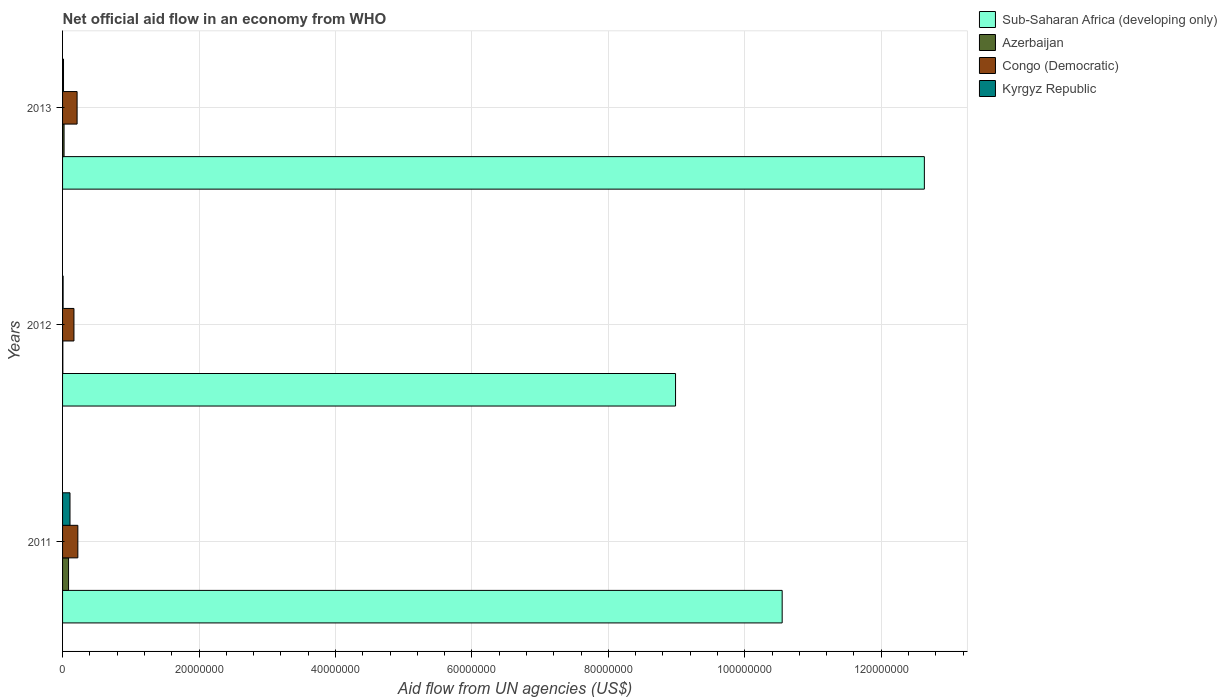How many bars are there on the 2nd tick from the top?
Offer a very short reply. 4. How many bars are there on the 3rd tick from the bottom?
Provide a succinct answer. 4. What is the label of the 1st group of bars from the top?
Provide a short and direct response. 2013. What is the net official aid flow in Kyrgyz Republic in 2011?
Your response must be concise. 1.09e+06. Across all years, what is the maximum net official aid flow in Congo (Democratic)?
Provide a short and direct response. 2.24e+06. In which year was the net official aid flow in Congo (Democratic) maximum?
Offer a very short reply. 2011. In which year was the net official aid flow in Kyrgyz Republic minimum?
Ensure brevity in your answer.  2012. What is the total net official aid flow in Congo (Democratic) in the graph?
Your answer should be very brief. 6.04e+06. What is the difference between the net official aid flow in Sub-Saharan Africa (developing only) in 2011 and the net official aid flow in Kyrgyz Republic in 2012?
Give a very brief answer. 1.05e+08. What is the average net official aid flow in Kyrgyz Republic per year?
Make the answer very short. 4.37e+05. In the year 2012, what is the difference between the net official aid flow in Congo (Democratic) and net official aid flow in Azerbaijan?
Provide a succinct answer. 1.63e+06. In how many years, is the net official aid flow in Kyrgyz Republic greater than 112000000 US$?
Offer a very short reply. 0. What is the ratio of the net official aid flow in Congo (Democratic) in 2012 to that in 2013?
Offer a very short reply. 0.78. Is the difference between the net official aid flow in Congo (Democratic) in 2012 and 2013 greater than the difference between the net official aid flow in Azerbaijan in 2012 and 2013?
Keep it short and to the point. No. What is the difference between the highest and the second highest net official aid flow in Sub-Saharan Africa (developing only)?
Your answer should be very brief. 2.08e+07. What is the difference between the highest and the lowest net official aid flow in Kyrgyz Republic?
Keep it short and to the point. 1.01e+06. What does the 3rd bar from the top in 2013 represents?
Your answer should be very brief. Azerbaijan. What does the 3rd bar from the bottom in 2012 represents?
Your answer should be compact. Congo (Democratic). How many years are there in the graph?
Offer a very short reply. 3. What is the difference between two consecutive major ticks on the X-axis?
Offer a very short reply. 2.00e+07. Are the values on the major ticks of X-axis written in scientific E-notation?
Make the answer very short. No. Does the graph contain any zero values?
Ensure brevity in your answer.  No. Where does the legend appear in the graph?
Offer a very short reply. Top right. How many legend labels are there?
Offer a terse response. 4. How are the legend labels stacked?
Provide a short and direct response. Vertical. What is the title of the graph?
Ensure brevity in your answer.  Net official aid flow in an economy from WHO. What is the label or title of the X-axis?
Offer a very short reply. Aid flow from UN agencies (US$). What is the Aid flow from UN agencies (US$) of Sub-Saharan Africa (developing only) in 2011?
Your answer should be very brief. 1.05e+08. What is the Aid flow from UN agencies (US$) of Azerbaijan in 2011?
Make the answer very short. 8.80e+05. What is the Aid flow from UN agencies (US$) of Congo (Democratic) in 2011?
Keep it short and to the point. 2.24e+06. What is the Aid flow from UN agencies (US$) in Kyrgyz Republic in 2011?
Ensure brevity in your answer.  1.09e+06. What is the Aid flow from UN agencies (US$) of Sub-Saharan Africa (developing only) in 2012?
Provide a succinct answer. 8.98e+07. What is the Aid flow from UN agencies (US$) in Congo (Democratic) in 2012?
Your response must be concise. 1.67e+06. What is the Aid flow from UN agencies (US$) of Sub-Saharan Africa (developing only) in 2013?
Provide a short and direct response. 1.26e+08. What is the Aid flow from UN agencies (US$) in Congo (Democratic) in 2013?
Provide a succinct answer. 2.13e+06. Across all years, what is the maximum Aid flow from UN agencies (US$) in Sub-Saharan Africa (developing only)?
Ensure brevity in your answer.  1.26e+08. Across all years, what is the maximum Aid flow from UN agencies (US$) of Azerbaijan?
Your answer should be very brief. 8.80e+05. Across all years, what is the maximum Aid flow from UN agencies (US$) of Congo (Democratic)?
Offer a terse response. 2.24e+06. Across all years, what is the maximum Aid flow from UN agencies (US$) of Kyrgyz Republic?
Offer a terse response. 1.09e+06. Across all years, what is the minimum Aid flow from UN agencies (US$) of Sub-Saharan Africa (developing only)?
Keep it short and to the point. 8.98e+07. Across all years, what is the minimum Aid flow from UN agencies (US$) of Azerbaijan?
Offer a very short reply. 4.00e+04. Across all years, what is the minimum Aid flow from UN agencies (US$) of Congo (Democratic)?
Offer a very short reply. 1.67e+06. Across all years, what is the minimum Aid flow from UN agencies (US$) of Kyrgyz Republic?
Offer a terse response. 8.00e+04. What is the total Aid flow from UN agencies (US$) in Sub-Saharan Africa (developing only) in the graph?
Keep it short and to the point. 3.22e+08. What is the total Aid flow from UN agencies (US$) in Azerbaijan in the graph?
Keep it short and to the point. 1.14e+06. What is the total Aid flow from UN agencies (US$) of Congo (Democratic) in the graph?
Offer a terse response. 6.04e+06. What is the total Aid flow from UN agencies (US$) of Kyrgyz Republic in the graph?
Keep it short and to the point. 1.31e+06. What is the difference between the Aid flow from UN agencies (US$) of Sub-Saharan Africa (developing only) in 2011 and that in 2012?
Keep it short and to the point. 1.56e+07. What is the difference between the Aid flow from UN agencies (US$) in Azerbaijan in 2011 and that in 2012?
Provide a short and direct response. 8.40e+05. What is the difference between the Aid flow from UN agencies (US$) of Congo (Democratic) in 2011 and that in 2012?
Provide a succinct answer. 5.70e+05. What is the difference between the Aid flow from UN agencies (US$) in Kyrgyz Republic in 2011 and that in 2012?
Your response must be concise. 1.01e+06. What is the difference between the Aid flow from UN agencies (US$) in Sub-Saharan Africa (developing only) in 2011 and that in 2013?
Provide a short and direct response. -2.08e+07. What is the difference between the Aid flow from UN agencies (US$) of Congo (Democratic) in 2011 and that in 2013?
Provide a succinct answer. 1.10e+05. What is the difference between the Aid flow from UN agencies (US$) of Kyrgyz Republic in 2011 and that in 2013?
Give a very brief answer. 9.50e+05. What is the difference between the Aid flow from UN agencies (US$) in Sub-Saharan Africa (developing only) in 2012 and that in 2013?
Offer a very short reply. -3.65e+07. What is the difference between the Aid flow from UN agencies (US$) of Azerbaijan in 2012 and that in 2013?
Ensure brevity in your answer.  -1.80e+05. What is the difference between the Aid flow from UN agencies (US$) of Congo (Democratic) in 2012 and that in 2013?
Offer a terse response. -4.60e+05. What is the difference between the Aid flow from UN agencies (US$) of Kyrgyz Republic in 2012 and that in 2013?
Keep it short and to the point. -6.00e+04. What is the difference between the Aid flow from UN agencies (US$) of Sub-Saharan Africa (developing only) in 2011 and the Aid flow from UN agencies (US$) of Azerbaijan in 2012?
Ensure brevity in your answer.  1.05e+08. What is the difference between the Aid flow from UN agencies (US$) of Sub-Saharan Africa (developing only) in 2011 and the Aid flow from UN agencies (US$) of Congo (Democratic) in 2012?
Offer a very short reply. 1.04e+08. What is the difference between the Aid flow from UN agencies (US$) in Sub-Saharan Africa (developing only) in 2011 and the Aid flow from UN agencies (US$) in Kyrgyz Republic in 2012?
Make the answer very short. 1.05e+08. What is the difference between the Aid flow from UN agencies (US$) in Azerbaijan in 2011 and the Aid flow from UN agencies (US$) in Congo (Democratic) in 2012?
Your response must be concise. -7.90e+05. What is the difference between the Aid flow from UN agencies (US$) of Congo (Democratic) in 2011 and the Aid flow from UN agencies (US$) of Kyrgyz Republic in 2012?
Provide a succinct answer. 2.16e+06. What is the difference between the Aid flow from UN agencies (US$) in Sub-Saharan Africa (developing only) in 2011 and the Aid flow from UN agencies (US$) in Azerbaijan in 2013?
Give a very brief answer. 1.05e+08. What is the difference between the Aid flow from UN agencies (US$) in Sub-Saharan Africa (developing only) in 2011 and the Aid flow from UN agencies (US$) in Congo (Democratic) in 2013?
Offer a very short reply. 1.03e+08. What is the difference between the Aid flow from UN agencies (US$) in Sub-Saharan Africa (developing only) in 2011 and the Aid flow from UN agencies (US$) in Kyrgyz Republic in 2013?
Make the answer very short. 1.05e+08. What is the difference between the Aid flow from UN agencies (US$) of Azerbaijan in 2011 and the Aid flow from UN agencies (US$) of Congo (Democratic) in 2013?
Give a very brief answer. -1.25e+06. What is the difference between the Aid flow from UN agencies (US$) in Azerbaijan in 2011 and the Aid flow from UN agencies (US$) in Kyrgyz Republic in 2013?
Offer a terse response. 7.40e+05. What is the difference between the Aid flow from UN agencies (US$) of Congo (Democratic) in 2011 and the Aid flow from UN agencies (US$) of Kyrgyz Republic in 2013?
Make the answer very short. 2.10e+06. What is the difference between the Aid flow from UN agencies (US$) in Sub-Saharan Africa (developing only) in 2012 and the Aid flow from UN agencies (US$) in Azerbaijan in 2013?
Keep it short and to the point. 8.96e+07. What is the difference between the Aid flow from UN agencies (US$) of Sub-Saharan Africa (developing only) in 2012 and the Aid flow from UN agencies (US$) of Congo (Democratic) in 2013?
Ensure brevity in your answer.  8.77e+07. What is the difference between the Aid flow from UN agencies (US$) in Sub-Saharan Africa (developing only) in 2012 and the Aid flow from UN agencies (US$) in Kyrgyz Republic in 2013?
Offer a terse response. 8.97e+07. What is the difference between the Aid flow from UN agencies (US$) in Azerbaijan in 2012 and the Aid flow from UN agencies (US$) in Congo (Democratic) in 2013?
Keep it short and to the point. -2.09e+06. What is the difference between the Aid flow from UN agencies (US$) in Azerbaijan in 2012 and the Aid flow from UN agencies (US$) in Kyrgyz Republic in 2013?
Make the answer very short. -1.00e+05. What is the difference between the Aid flow from UN agencies (US$) in Congo (Democratic) in 2012 and the Aid flow from UN agencies (US$) in Kyrgyz Republic in 2013?
Provide a short and direct response. 1.53e+06. What is the average Aid flow from UN agencies (US$) in Sub-Saharan Africa (developing only) per year?
Give a very brief answer. 1.07e+08. What is the average Aid flow from UN agencies (US$) in Azerbaijan per year?
Offer a terse response. 3.80e+05. What is the average Aid flow from UN agencies (US$) of Congo (Democratic) per year?
Provide a short and direct response. 2.01e+06. What is the average Aid flow from UN agencies (US$) of Kyrgyz Republic per year?
Ensure brevity in your answer.  4.37e+05. In the year 2011, what is the difference between the Aid flow from UN agencies (US$) of Sub-Saharan Africa (developing only) and Aid flow from UN agencies (US$) of Azerbaijan?
Provide a succinct answer. 1.05e+08. In the year 2011, what is the difference between the Aid flow from UN agencies (US$) in Sub-Saharan Africa (developing only) and Aid flow from UN agencies (US$) in Congo (Democratic)?
Your answer should be compact. 1.03e+08. In the year 2011, what is the difference between the Aid flow from UN agencies (US$) of Sub-Saharan Africa (developing only) and Aid flow from UN agencies (US$) of Kyrgyz Republic?
Keep it short and to the point. 1.04e+08. In the year 2011, what is the difference between the Aid flow from UN agencies (US$) of Azerbaijan and Aid flow from UN agencies (US$) of Congo (Democratic)?
Offer a very short reply. -1.36e+06. In the year 2011, what is the difference between the Aid flow from UN agencies (US$) in Congo (Democratic) and Aid flow from UN agencies (US$) in Kyrgyz Republic?
Give a very brief answer. 1.15e+06. In the year 2012, what is the difference between the Aid flow from UN agencies (US$) of Sub-Saharan Africa (developing only) and Aid flow from UN agencies (US$) of Azerbaijan?
Your answer should be very brief. 8.98e+07. In the year 2012, what is the difference between the Aid flow from UN agencies (US$) of Sub-Saharan Africa (developing only) and Aid flow from UN agencies (US$) of Congo (Democratic)?
Offer a very short reply. 8.82e+07. In the year 2012, what is the difference between the Aid flow from UN agencies (US$) of Sub-Saharan Africa (developing only) and Aid flow from UN agencies (US$) of Kyrgyz Republic?
Provide a short and direct response. 8.98e+07. In the year 2012, what is the difference between the Aid flow from UN agencies (US$) in Azerbaijan and Aid flow from UN agencies (US$) in Congo (Democratic)?
Provide a short and direct response. -1.63e+06. In the year 2012, what is the difference between the Aid flow from UN agencies (US$) of Congo (Democratic) and Aid flow from UN agencies (US$) of Kyrgyz Republic?
Offer a terse response. 1.59e+06. In the year 2013, what is the difference between the Aid flow from UN agencies (US$) in Sub-Saharan Africa (developing only) and Aid flow from UN agencies (US$) in Azerbaijan?
Your response must be concise. 1.26e+08. In the year 2013, what is the difference between the Aid flow from UN agencies (US$) in Sub-Saharan Africa (developing only) and Aid flow from UN agencies (US$) in Congo (Democratic)?
Give a very brief answer. 1.24e+08. In the year 2013, what is the difference between the Aid flow from UN agencies (US$) of Sub-Saharan Africa (developing only) and Aid flow from UN agencies (US$) of Kyrgyz Republic?
Make the answer very short. 1.26e+08. In the year 2013, what is the difference between the Aid flow from UN agencies (US$) of Azerbaijan and Aid flow from UN agencies (US$) of Congo (Democratic)?
Ensure brevity in your answer.  -1.91e+06. In the year 2013, what is the difference between the Aid flow from UN agencies (US$) of Azerbaijan and Aid flow from UN agencies (US$) of Kyrgyz Republic?
Make the answer very short. 8.00e+04. In the year 2013, what is the difference between the Aid flow from UN agencies (US$) of Congo (Democratic) and Aid flow from UN agencies (US$) of Kyrgyz Republic?
Keep it short and to the point. 1.99e+06. What is the ratio of the Aid flow from UN agencies (US$) in Sub-Saharan Africa (developing only) in 2011 to that in 2012?
Offer a very short reply. 1.17. What is the ratio of the Aid flow from UN agencies (US$) of Azerbaijan in 2011 to that in 2012?
Ensure brevity in your answer.  22. What is the ratio of the Aid flow from UN agencies (US$) of Congo (Democratic) in 2011 to that in 2012?
Provide a short and direct response. 1.34. What is the ratio of the Aid flow from UN agencies (US$) in Kyrgyz Republic in 2011 to that in 2012?
Offer a very short reply. 13.62. What is the ratio of the Aid flow from UN agencies (US$) in Sub-Saharan Africa (developing only) in 2011 to that in 2013?
Provide a short and direct response. 0.83. What is the ratio of the Aid flow from UN agencies (US$) of Azerbaijan in 2011 to that in 2013?
Provide a succinct answer. 4. What is the ratio of the Aid flow from UN agencies (US$) in Congo (Democratic) in 2011 to that in 2013?
Make the answer very short. 1.05. What is the ratio of the Aid flow from UN agencies (US$) of Kyrgyz Republic in 2011 to that in 2013?
Ensure brevity in your answer.  7.79. What is the ratio of the Aid flow from UN agencies (US$) in Sub-Saharan Africa (developing only) in 2012 to that in 2013?
Make the answer very short. 0.71. What is the ratio of the Aid flow from UN agencies (US$) of Azerbaijan in 2012 to that in 2013?
Offer a very short reply. 0.18. What is the ratio of the Aid flow from UN agencies (US$) in Congo (Democratic) in 2012 to that in 2013?
Your answer should be very brief. 0.78. What is the ratio of the Aid flow from UN agencies (US$) of Kyrgyz Republic in 2012 to that in 2013?
Ensure brevity in your answer.  0.57. What is the difference between the highest and the second highest Aid flow from UN agencies (US$) of Sub-Saharan Africa (developing only)?
Offer a very short reply. 2.08e+07. What is the difference between the highest and the second highest Aid flow from UN agencies (US$) in Kyrgyz Republic?
Provide a short and direct response. 9.50e+05. What is the difference between the highest and the lowest Aid flow from UN agencies (US$) in Sub-Saharan Africa (developing only)?
Your response must be concise. 3.65e+07. What is the difference between the highest and the lowest Aid flow from UN agencies (US$) in Azerbaijan?
Provide a succinct answer. 8.40e+05. What is the difference between the highest and the lowest Aid flow from UN agencies (US$) of Congo (Democratic)?
Your answer should be very brief. 5.70e+05. What is the difference between the highest and the lowest Aid flow from UN agencies (US$) of Kyrgyz Republic?
Offer a very short reply. 1.01e+06. 